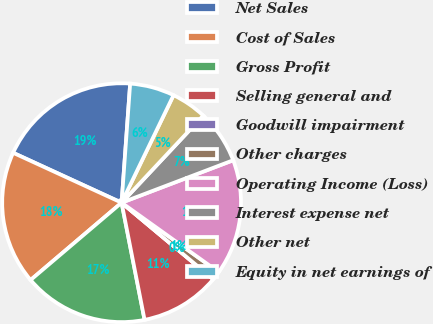<chart> <loc_0><loc_0><loc_500><loc_500><pie_chart><fcel>Net Sales<fcel>Cost of Sales<fcel>Gross Profit<fcel>Selling general and<fcel>Goodwill impairment<fcel>Other charges<fcel>Operating Income (Loss)<fcel>Interest expense net<fcel>Other net<fcel>Equity in net earnings of<nl><fcel>19.28%<fcel>18.07%<fcel>16.87%<fcel>10.84%<fcel>0.0%<fcel>1.2%<fcel>15.66%<fcel>7.23%<fcel>4.82%<fcel>6.02%<nl></chart> 